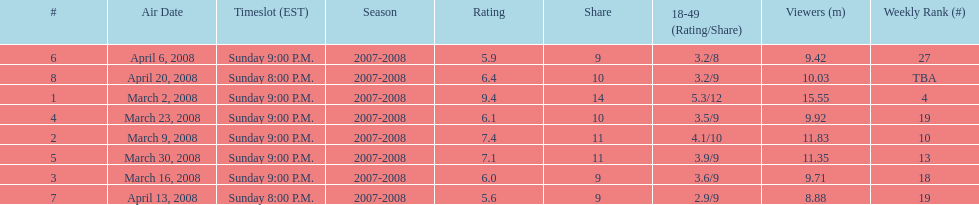Did the season finish at an earlier or later timeslot? Earlier. 